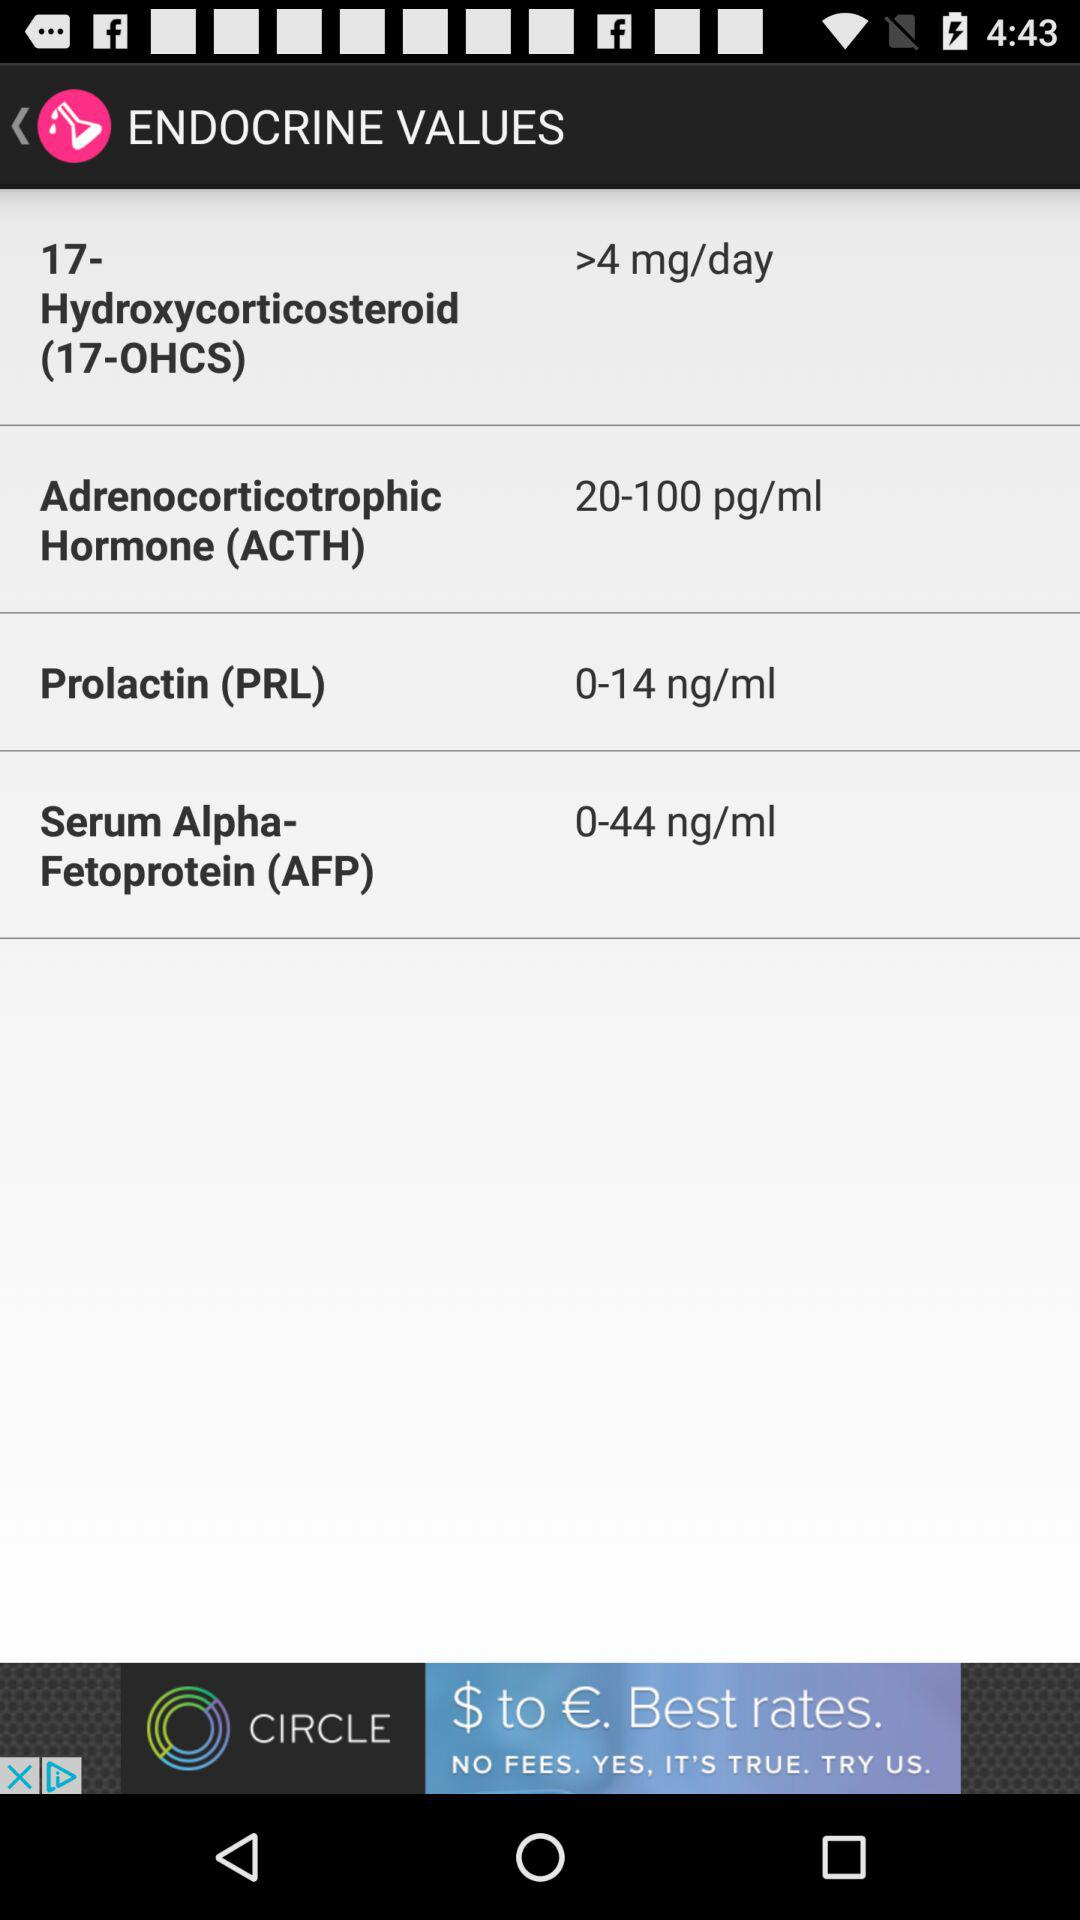What is the value of prolactin (PRL)? The value of prolactin (PRL) is 0–14 ng/mL. 